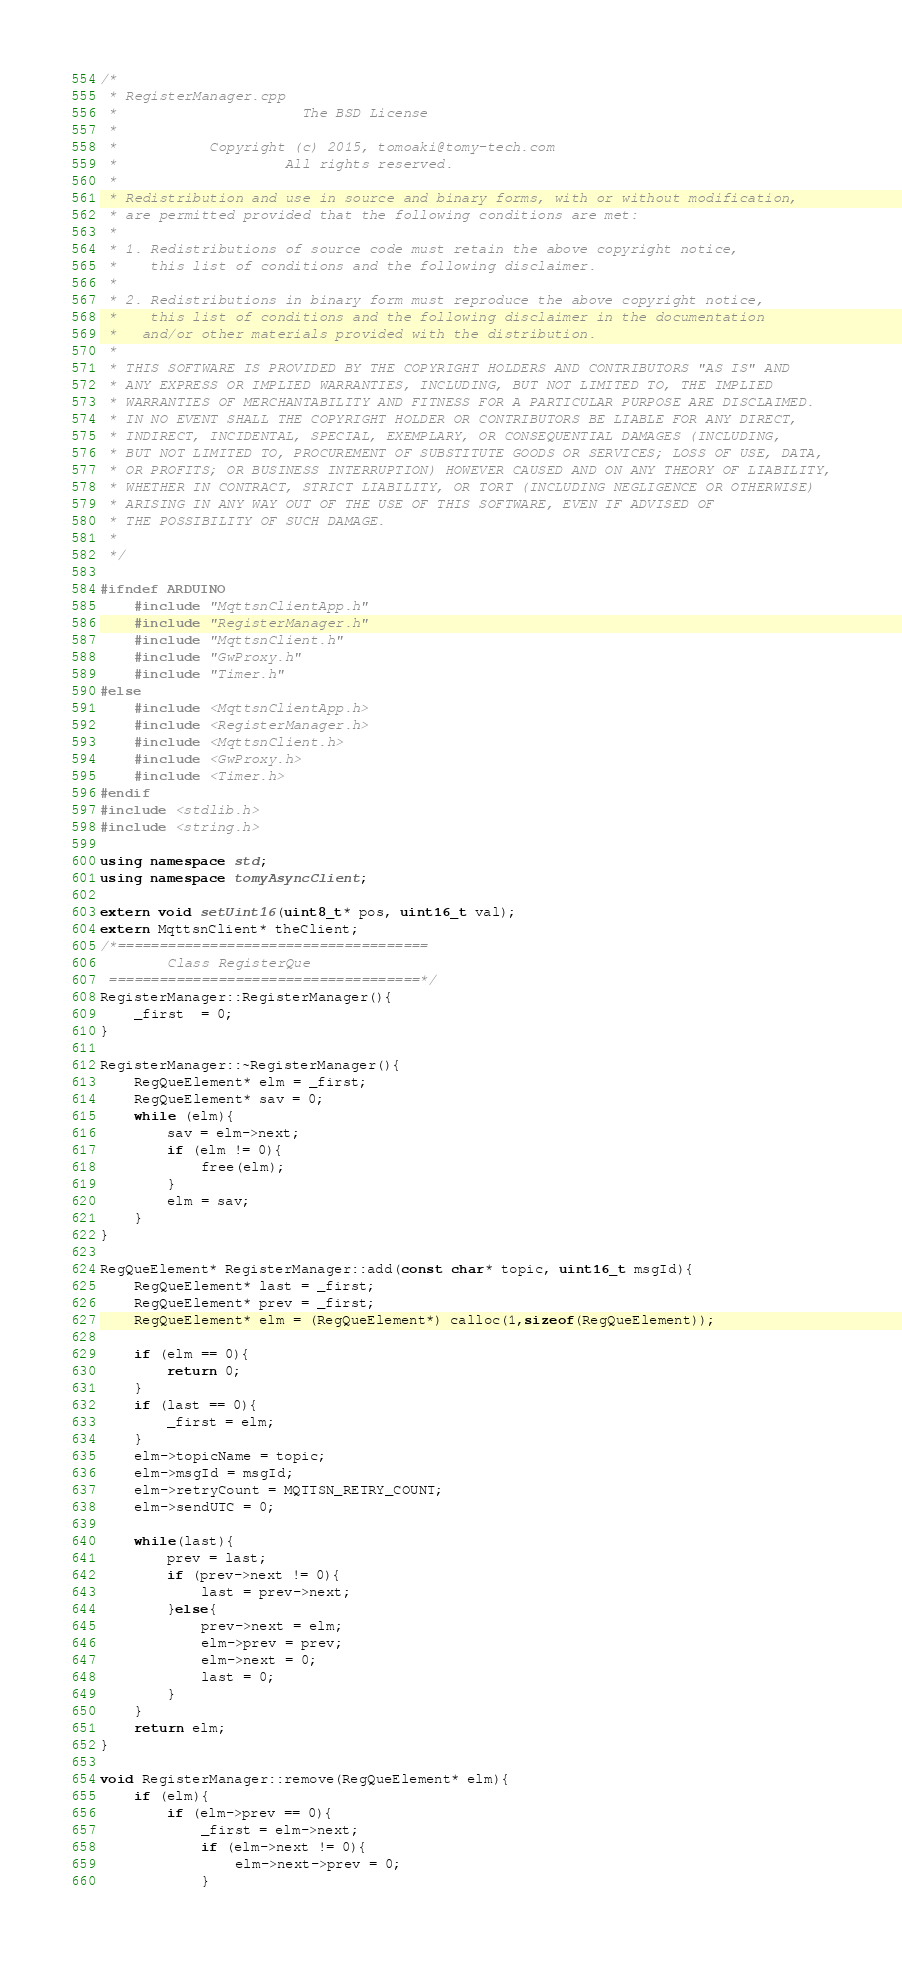<code> <loc_0><loc_0><loc_500><loc_500><_C++_>/*
 * RegisterManager.cpp
 *                      The BSD License
 *
 *           Copyright (c) 2015, tomoaki@tomy-tech.com
 *                    All rights reserved.
 *
 * Redistribution and use in source and binary forms, with or without modification,
 * are permitted provided that the following conditions are met:
 *
 * 1. Redistributions of source code must retain the above copyright notice,
 *    this list of conditions and the following disclaimer.
 *
 * 2. Redistributions in binary form must reproduce the above copyright notice,
 *    this list of conditions and the following disclaimer in the documentation
 *   and/or other materials provided with the distribution.
 *
 * THIS SOFTWARE IS PROVIDED BY THE COPYRIGHT HOLDERS AND CONTRIBUTORS "AS IS" AND
 * ANY EXPRESS OR IMPLIED WARRANTIES, INCLUDING, BUT NOT LIMITED TO, THE IMPLIED
 * WARRANTIES OF MERCHANTABILITY AND FITNESS FOR A PARTICULAR PURPOSE ARE DISCLAIMED.
 * IN NO EVENT SHALL THE COPYRIGHT HOLDER OR CONTRIBUTORS BE LIABLE FOR ANY DIRECT,
 * INDIRECT, INCIDENTAL, SPECIAL, EXEMPLARY, OR CONSEQUENTIAL DAMAGES (INCLUDING,
 * BUT NOT LIMITED TO, PROCUREMENT OF SUBSTITUTE GOODS OR SERVICES; LOSS OF USE, DATA,
 * OR PROFITS; OR BUSINESS INTERRUPTION) HOWEVER CAUSED AND ON ANY THEORY OF LIABILITY,
 * WHETHER IN CONTRACT, STRICT LIABILITY, OR TORT (INCLUDING NEGLIGENCE OR OTHERWISE)
 * ARISING IN ANY WAY OUT OF THE USE OF THIS SOFTWARE, EVEN IF ADVISED OF
 * THE POSSIBILITY OF SUCH DAMAGE.
 *
 */

#ifndef ARDUINO
  	#include "MqttsnClientApp.h"
	#include "RegisterManager.h"
	#include "MqttsnClient.h"
	#include "GwProxy.h"
	#include "Timer.h"
#else
  	#include <MqttsnClientApp.h>
	#include <RegisterManager.h>
	#include <MqttsnClient.h>
	#include <GwProxy.h>
	#include <Timer.h>
#endif
#include <stdlib.h>
#include <string.h>

using namespace std;
using namespace tomyAsyncClient;

extern void setUint16(uint8_t* pos, uint16_t val);
extern MqttsnClient* theClient;
/*=====================================
        Class RegisterQue
 =====================================*/
RegisterManager::RegisterManager(){
	_first  = 0;
}

RegisterManager::~RegisterManager(){
	RegQueElement* elm = _first;
	RegQueElement* sav = 0;
	while (elm){
		sav = elm->next;
		if (elm != 0){
			free(elm);
		}
		elm = sav;
	}
}

RegQueElement* RegisterManager::add(const char* topic, uint16_t msgId){
	RegQueElement* last = _first;
	RegQueElement* prev = _first;
	RegQueElement* elm = (RegQueElement*) calloc(1,sizeof(RegQueElement));

	if (elm == 0){
		return 0;
	}
	if (last == 0){
		_first = elm;
	}
	elm->topicName = topic;
	elm->msgId = msgId;
	elm->retryCount = MQTTSN_RETRY_COUNT;
	elm->sendUTC = 0;

	while(last){
		prev = last;
		if (prev->next != 0){
			last = prev->next;
		}else{
			prev->next = elm;
			elm->prev = prev;
			elm->next = 0;
			last = 0;
		}
	}
	return elm;
}

void RegisterManager::remove(RegQueElement* elm){
    if (elm){
    	if (elm->prev == 0){
    		_first = elm->next;
    		if (elm->next != 0){
    			elm->next->prev = 0;
    		}</code> 